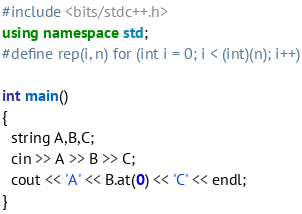Convert code to text. <code><loc_0><loc_0><loc_500><loc_500><_C++_>#include <bits/stdc++.h>
using namespace std;
#define rep(i, n) for (int i = 0; i < (int)(n); i++)

int main()
{
  string A,B,C;
  cin >> A >> B >> C;
  cout << 'A' << B.at(0) << 'C' << endl;
}
</code> 